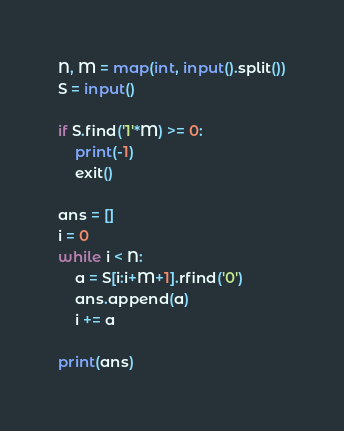Convert code to text. <code><loc_0><loc_0><loc_500><loc_500><_Python_>N, M = map(int, input().split())
S = input()

if S.find('1'*M) >= 0:
    print(-1)
    exit()

ans = []
i = 0
while i < N:
    a = S[i:i+M+1].rfind('0')
    ans.append(a)
    i += a

print(ans)
</code> 